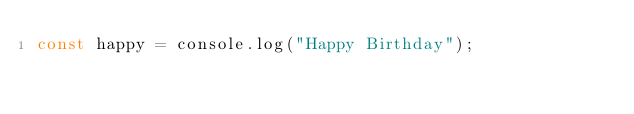Convert code to text. <code><loc_0><loc_0><loc_500><loc_500><_JavaScript_>const happy = console.log("Happy Birthday");
</code> 